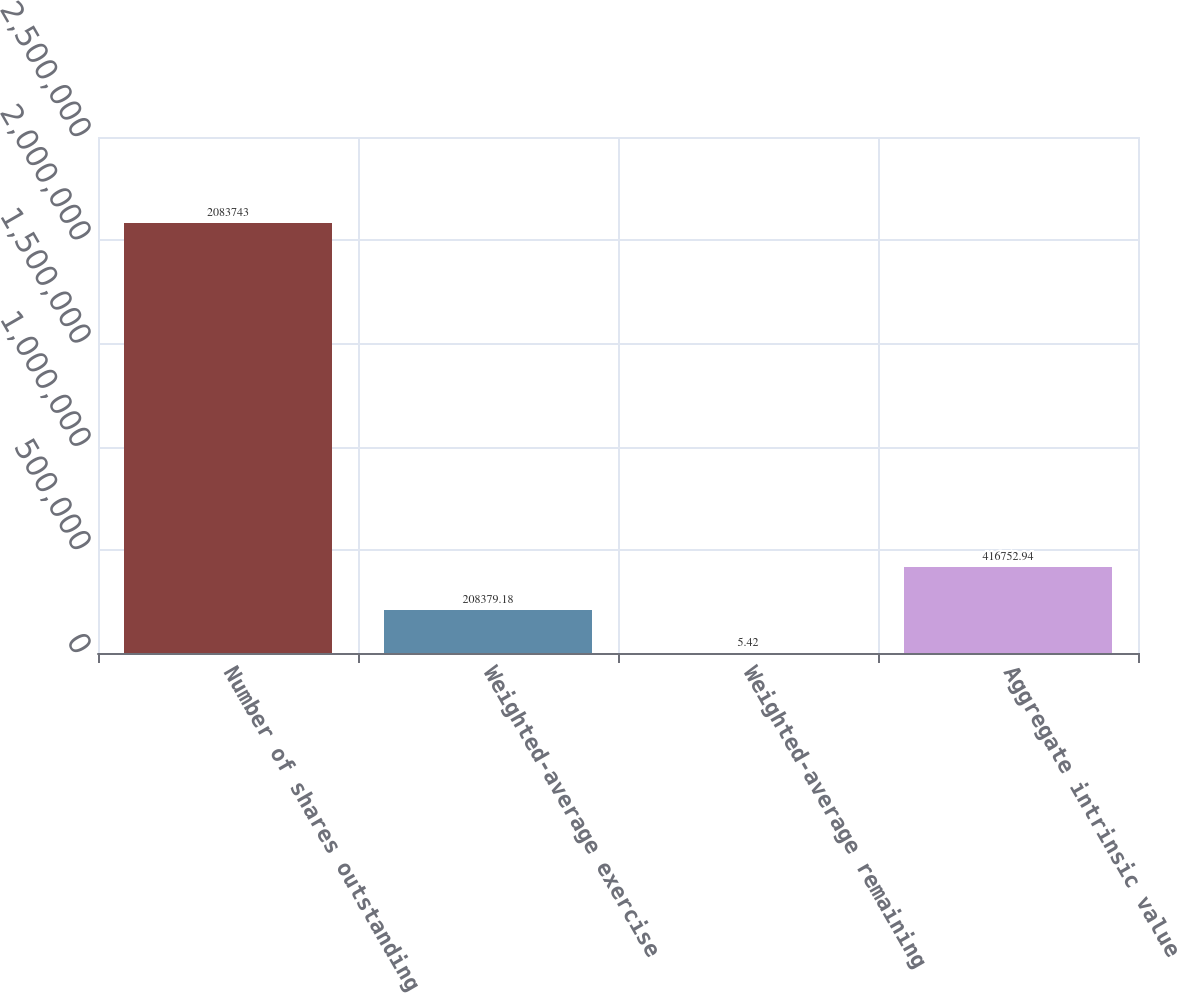Convert chart. <chart><loc_0><loc_0><loc_500><loc_500><bar_chart><fcel>Number of shares outstanding<fcel>Weighted-average exercise<fcel>Weighted-average remaining<fcel>Aggregate intrinsic value<nl><fcel>2.08374e+06<fcel>208379<fcel>5.42<fcel>416753<nl></chart> 